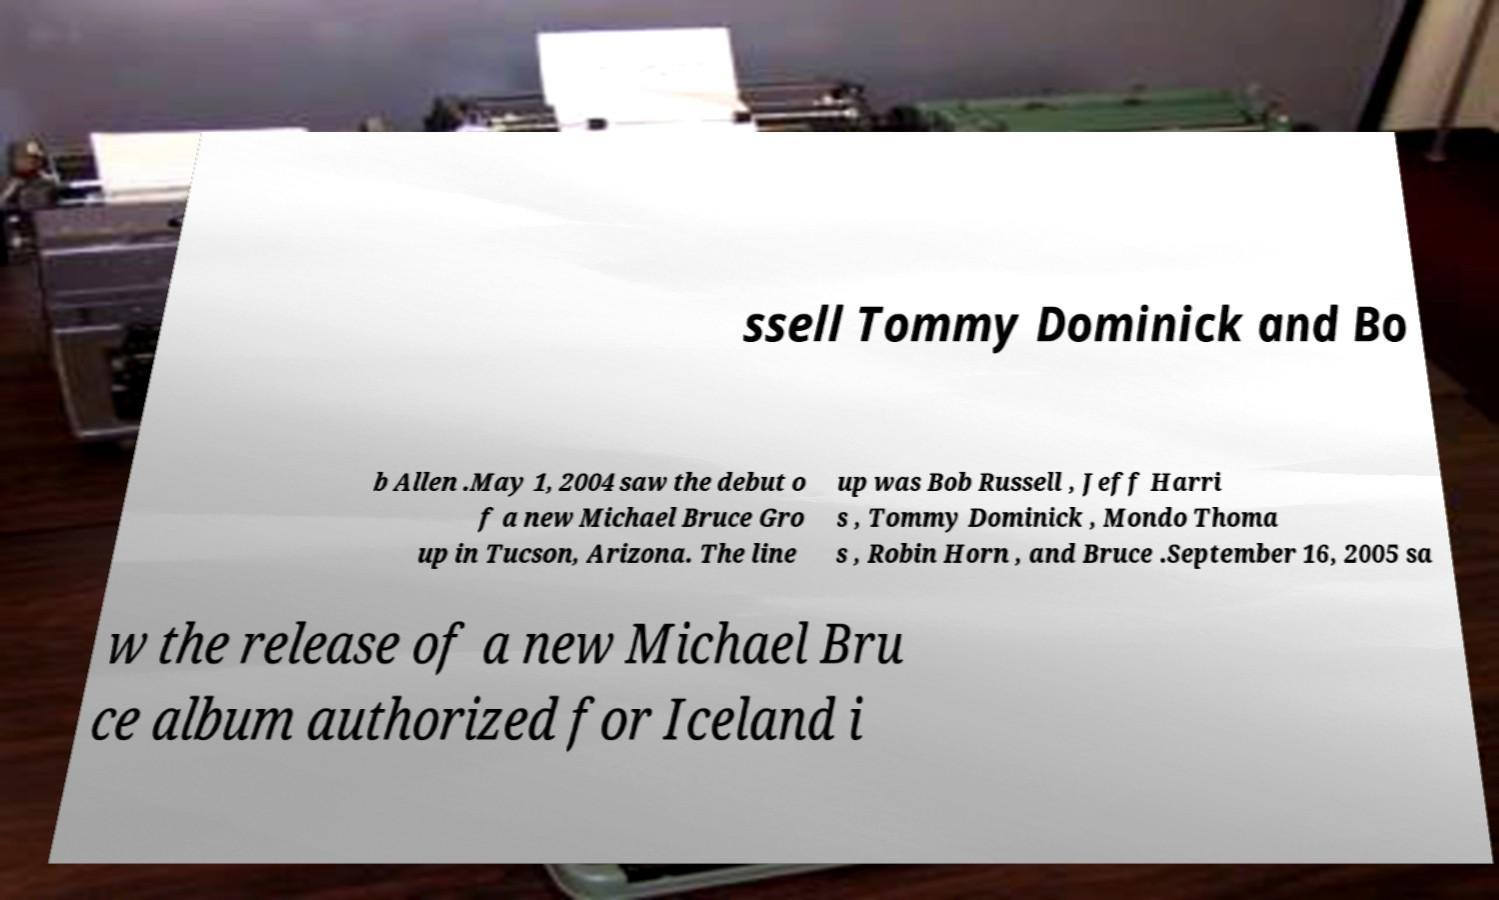Can you accurately transcribe the text from the provided image for me? ssell Tommy Dominick and Bo b Allen .May 1, 2004 saw the debut o f a new Michael Bruce Gro up in Tucson, Arizona. The line up was Bob Russell , Jeff Harri s , Tommy Dominick , Mondo Thoma s , Robin Horn , and Bruce .September 16, 2005 sa w the release of a new Michael Bru ce album authorized for Iceland i 